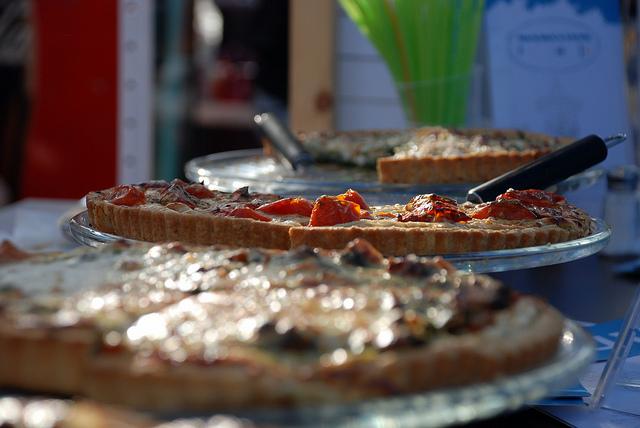Does this food look delicious?
Keep it brief. Yes. What kind of food is this?
Keep it brief. Pizza. What is present?
Answer briefly. Pizza. 